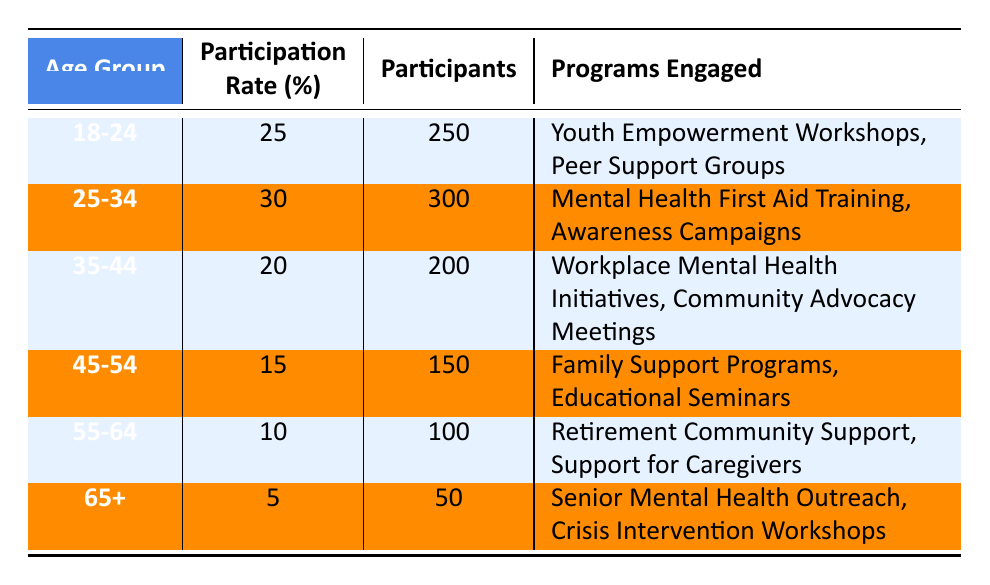What is the participation rate for the age group 25-34? The participation rate for the age group 25-34 is listed directly in the table, which shows a value of 30%.
Answer: 30% How many participants are involved in programs for the age group 45-54? The table shows that the number of participants in the age group 45-54 is 150.
Answer: 150 Which age group has the highest participation rate? By examining the participation rates listed in the table, the age group 25-34 has the highest participation rate at 30%.
Answer: 25-34 What is the total number of participants for age groups 18-24 and 35-44 combined? Adding the participants from both age groups, we have 250 (18-24) + 200 (35-44) = 450 participants.
Answer: 450 Is the participation rate for the 55-64 age group higher than that of the 45-54 age group? The participation rate for the 55-64 age group is 10%, while for the 45-54 age group, it is 15%. Therefore, the statement is false.
Answer: No What is the average participation rate across all age groups? To find the average, sum all the participation rates: (25 + 30 + 20 + 15 + 10 + 5) = 105; then divide by the number of groups (6): 105/6 = 17.5%.
Answer: 17.5% Which programs are engaged by participants in the 65+ age group? The table indicates that participants in the 65+ age group engage in "Senior Mental Health Outreach" and "Crisis Intervention Workshops."
Answer: Senior Mental Health Outreach, Crisis Intervention Workshops If the participation rate for the age group 18-24 increases by 10%, what will be the new rate? The current participation rate for 18-24 is 25%; if it increases by 10%, the new rate will be 25 + 10 = 35%.
Answer: 35% What is the difference in the number of participants between the age groups 25-34 and 45-54? The number of participants in the 25-34 age group is 300, while in the 45-54 group it is 150. The difference is 300 - 150 = 150 participants.
Answer: 150 